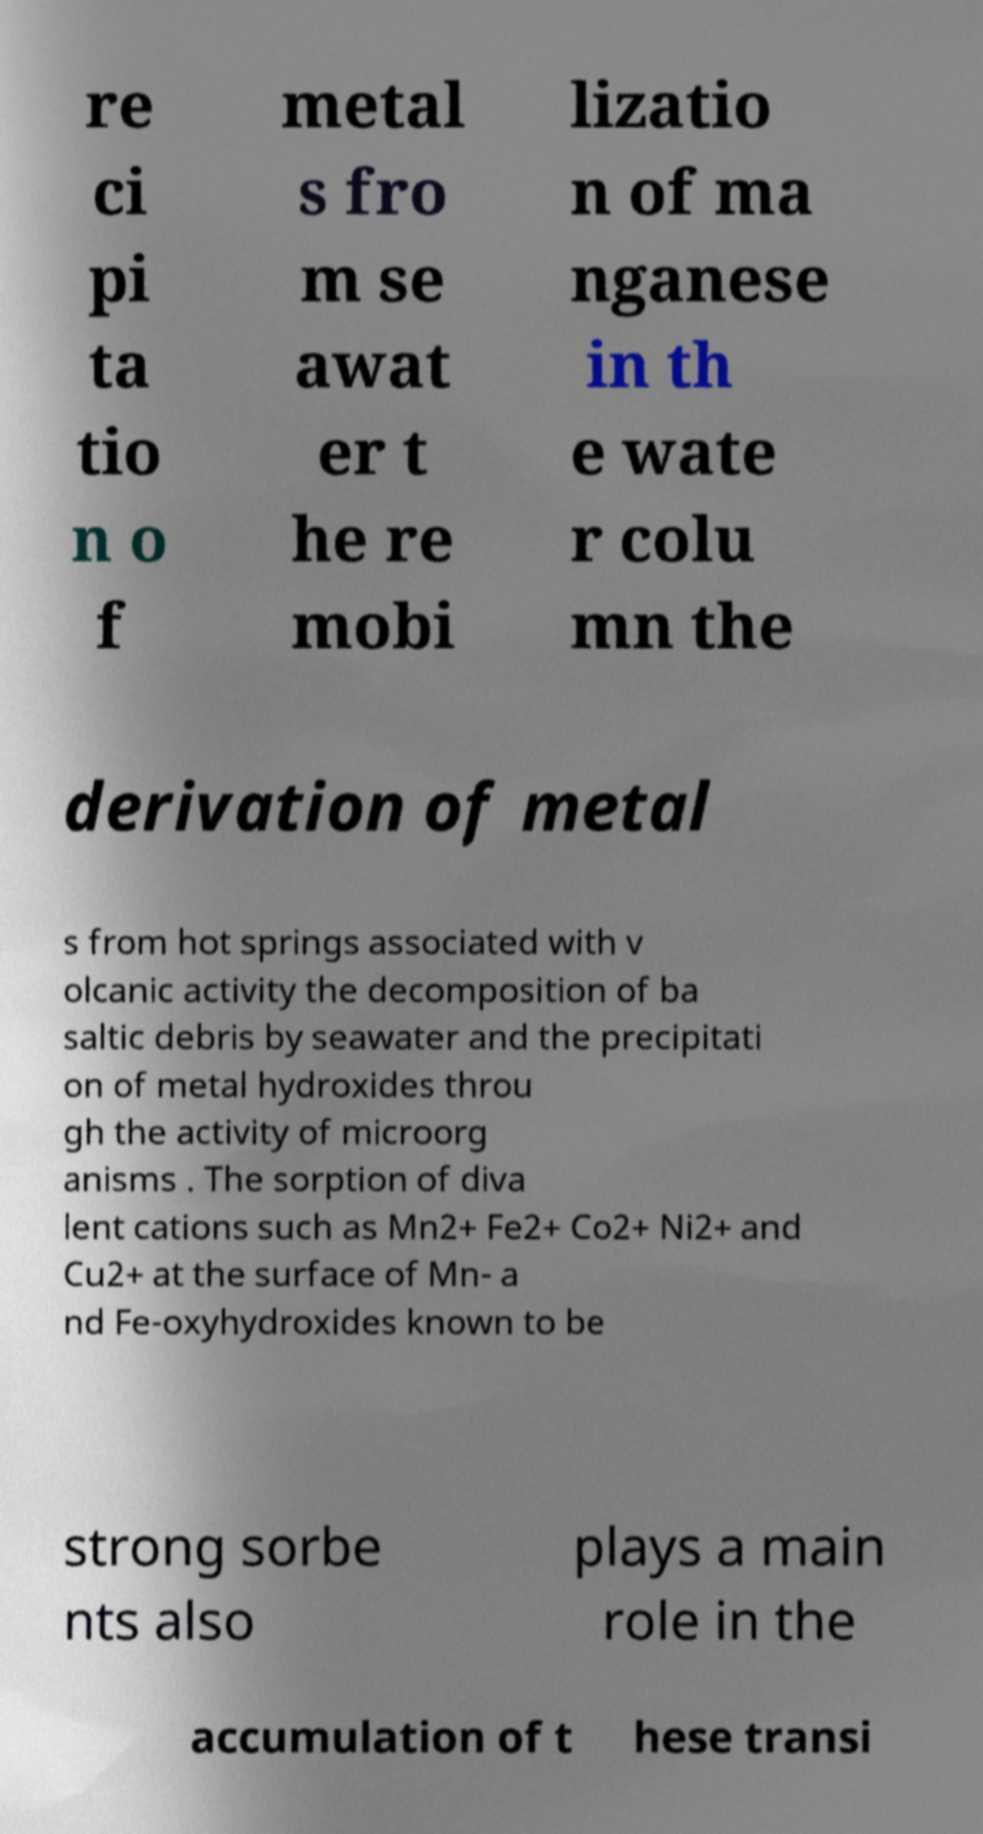Could you assist in decoding the text presented in this image and type it out clearly? re ci pi ta tio n o f metal s fro m se awat er t he re mobi lizatio n of ma nganese in th e wate r colu mn the derivation of metal s from hot springs associated with v olcanic activity the decomposition of ba saltic debris by seawater and the precipitati on of metal hydroxides throu gh the activity of microorg anisms . The sorption of diva lent cations such as Mn2+ Fe2+ Co2+ Ni2+ and Cu2+ at the surface of Mn- a nd Fe-oxyhydroxides known to be strong sorbe nts also plays a main role in the accumulation of t hese transi 